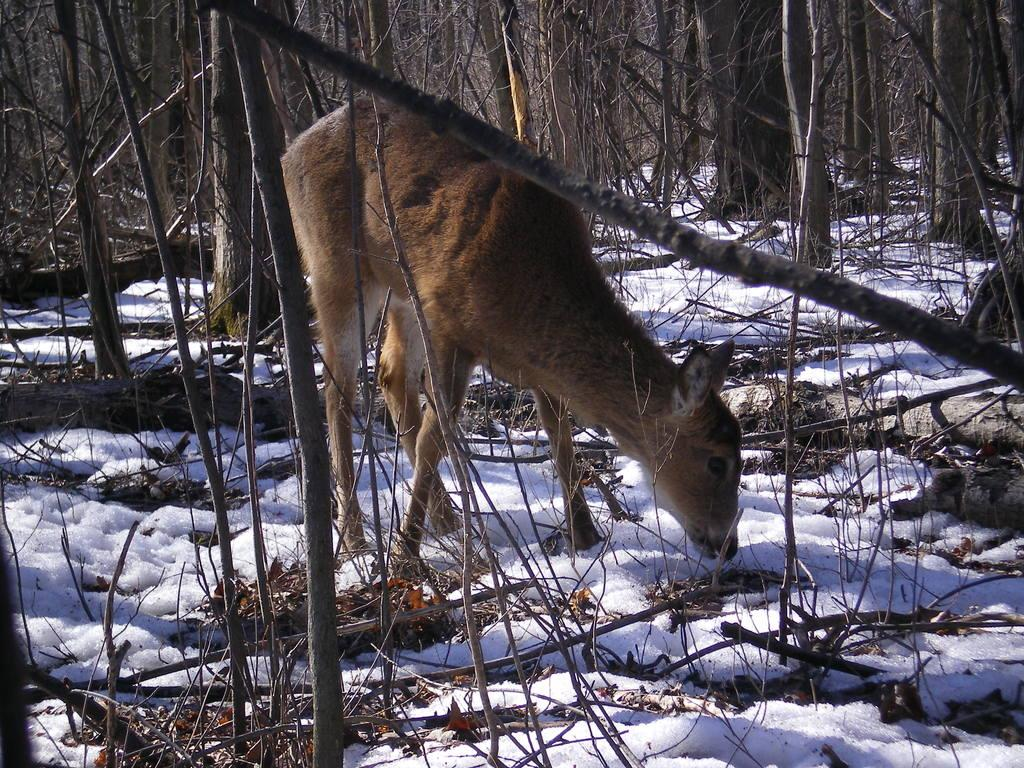What type of animal is in the image? The type of animal cannot be determined from the provided facts. What is the condition of the ground in the image? The surface has snow in the image. What can be seen in the background of the image? There are dried trees in the background of the image. How does the animal express its feelings of hate towards the coil in the image? There is no coil or expression of hate present in the image. 